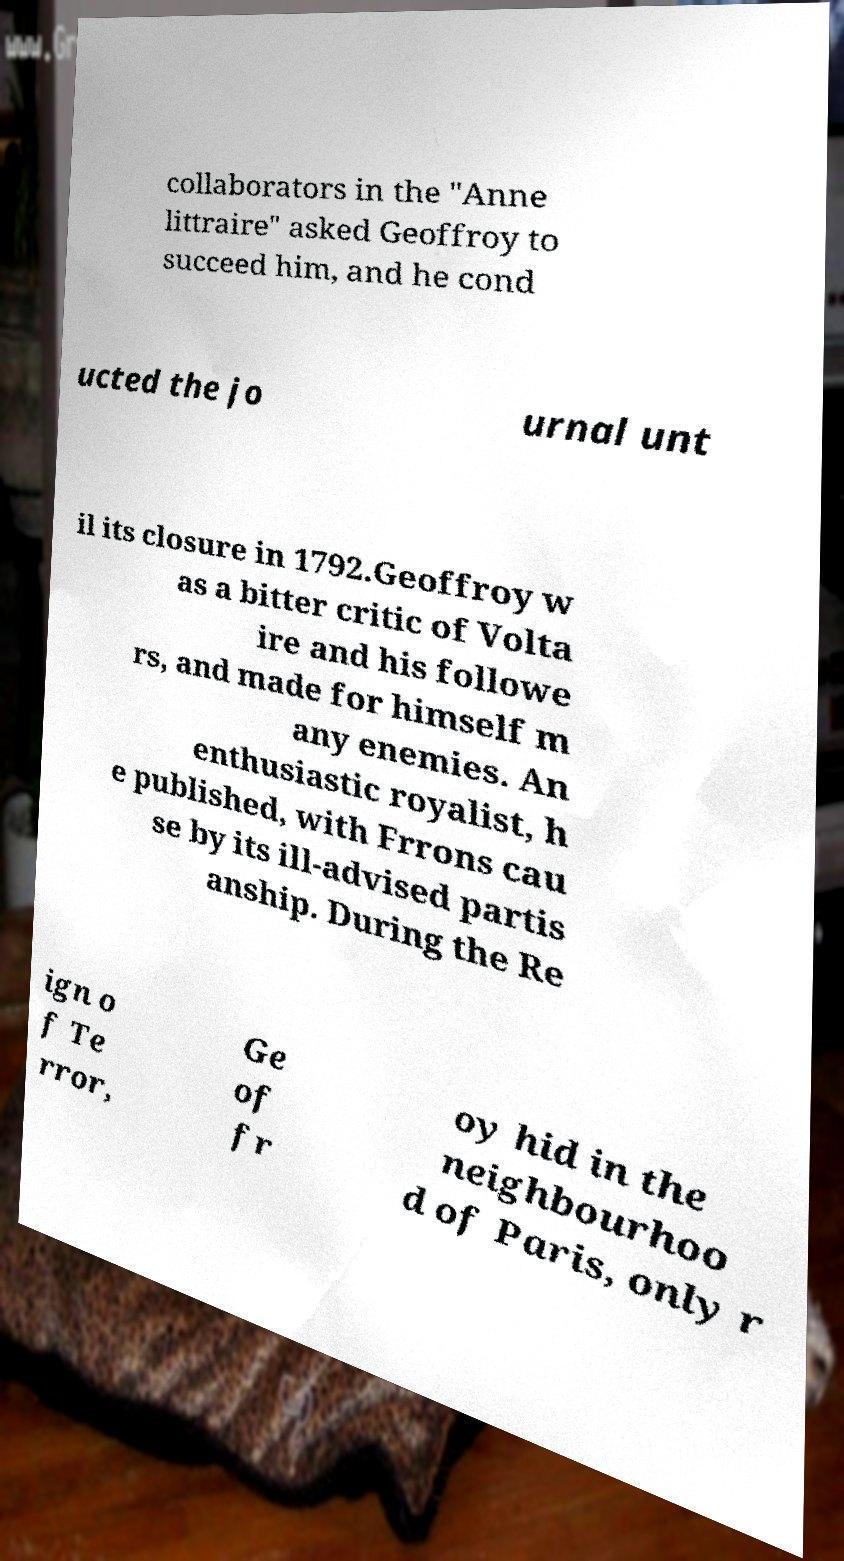For documentation purposes, I need the text within this image transcribed. Could you provide that? collaborators in the "Anne littraire" asked Geoffroy to succeed him, and he cond ucted the jo urnal unt il its closure in 1792.Geoffroy w as a bitter critic of Volta ire and his followe rs, and made for himself m any enemies. An enthusiastic royalist, h e published, with Frrons cau se by its ill-advised partis anship. During the Re ign o f Te rror, Ge of fr oy hid in the neighbourhoo d of Paris, only r 